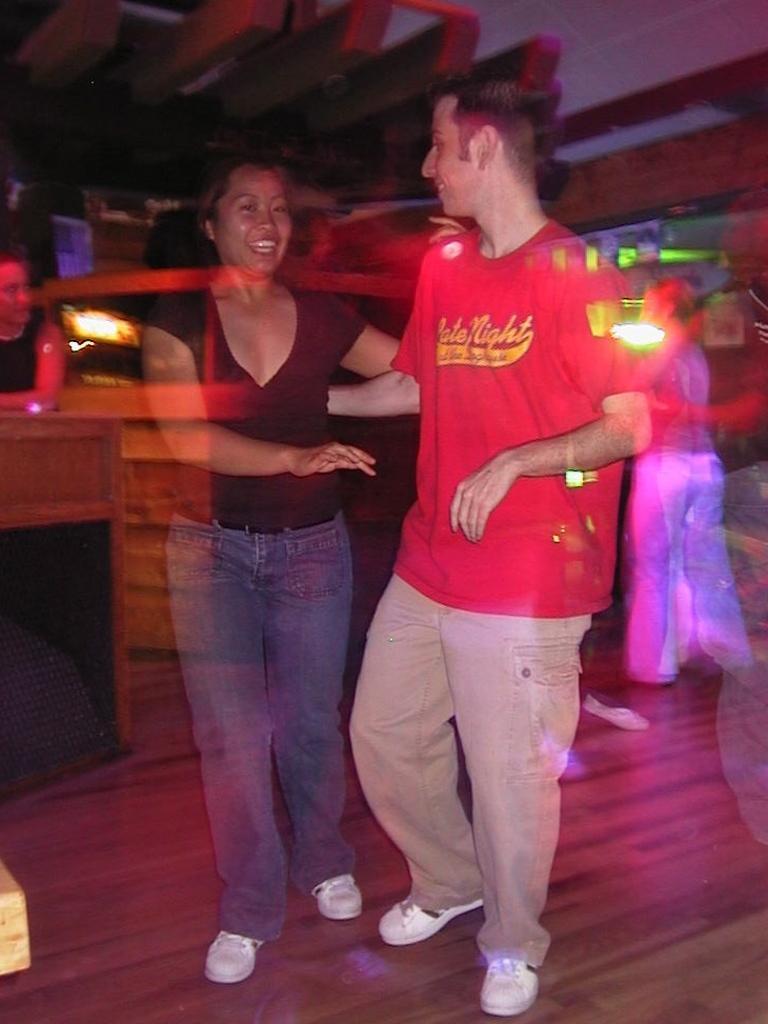In one or two sentences, can you explain what this image depicts? This picture is blur, in this picture we can see people, floor, table and lights. 